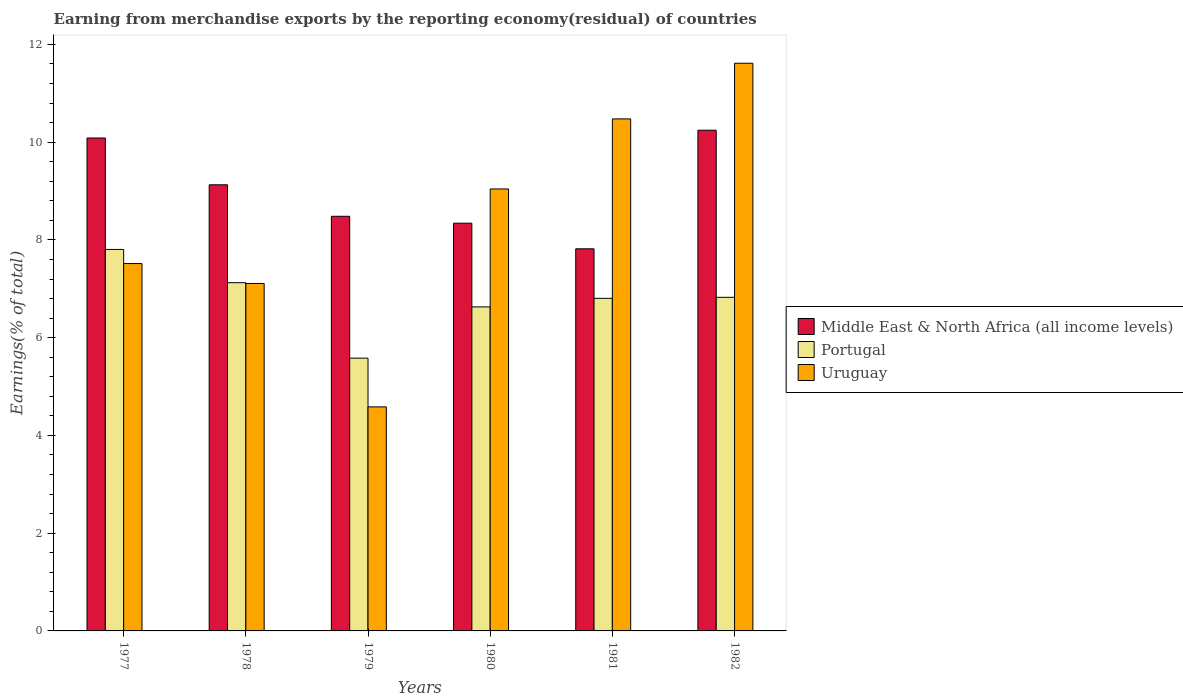Are the number of bars per tick equal to the number of legend labels?
Make the answer very short. Yes. Are the number of bars on each tick of the X-axis equal?
Make the answer very short. Yes. What is the label of the 4th group of bars from the left?
Your answer should be very brief. 1980. In how many cases, is the number of bars for a given year not equal to the number of legend labels?
Ensure brevity in your answer.  0. What is the percentage of amount earned from merchandise exports in Uruguay in 1981?
Offer a terse response. 10.48. Across all years, what is the maximum percentage of amount earned from merchandise exports in Portugal?
Offer a terse response. 7.81. Across all years, what is the minimum percentage of amount earned from merchandise exports in Portugal?
Make the answer very short. 5.58. In which year was the percentage of amount earned from merchandise exports in Middle East & North Africa (all income levels) maximum?
Provide a short and direct response. 1982. In which year was the percentage of amount earned from merchandise exports in Uruguay minimum?
Provide a short and direct response. 1979. What is the total percentage of amount earned from merchandise exports in Middle East & North Africa (all income levels) in the graph?
Offer a very short reply. 54.1. What is the difference between the percentage of amount earned from merchandise exports in Portugal in 1977 and that in 1979?
Your answer should be compact. 2.22. What is the difference between the percentage of amount earned from merchandise exports in Portugal in 1981 and the percentage of amount earned from merchandise exports in Middle East & North Africa (all income levels) in 1982?
Your answer should be compact. -3.44. What is the average percentage of amount earned from merchandise exports in Uruguay per year?
Your response must be concise. 8.39. In the year 1979, what is the difference between the percentage of amount earned from merchandise exports in Middle East & North Africa (all income levels) and percentage of amount earned from merchandise exports in Uruguay?
Keep it short and to the point. 3.9. What is the ratio of the percentage of amount earned from merchandise exports in Portugal in 1979 to that in 1982?
Your response must be concise. 0.82. What is the difference between the highest and the second highest percentage of amount earned from merchandise exports in Middle East & North Africa (all income levels)?
Offer a terse response. 0.16. What is the difference between the highest and the lowest percentage of amount earned from merchandise exports in Portugal?
Make the answer very short. 2.22. Is the sum of the percentage of amount earned from merchandise exports in Middle East & North Africa (all income levels) in 1977 and 1980 greater than the maximum percentage of amount earned from merchandise exports in Uruguay across all years?
Make the answer very short. Yes. What does the 1st bar from the left in 1980 represents?
Your answer should be very brief. Middle East & North Africa (all income levels). What does the 3rd bar from the right in 1977 represents?
Keep it short and to the point. Middle East & North Africa (all income levels). Is it the case that in every year, the sum of the percentage of amount earned from merchandise exports in Portugal and percentage of amount earned from merchandise exports in Uruguay is greater than the percentage of amount earned from merchandise exports in Middle East & North Africa (all income levels)?
Your answer should be very brief. Yes. How many bars are there?
Give a very brief answer. 18. Are all the bars in the graph horizontal?
Make the answer very short. No. How many years are there in the graph?
Give a very brief answer. 6. What is the title of the graph?
Provide a short and direct response. Earning from merchandise exports by the reporting economy(residual) of countries. What is the label or title of the Y-axis?
Provide a short and direct response. Earnings(% of total). What is the Earnings(% of total) of Middle East & North Africa (all income levels) in 1977?
Offer a terse response. 10.09. What is the Earnings(% of total) of Portugal in 1977?
Offer a terse response. 7.81. What is the Earnings(% of total) of Uruguay in 1977?
Your response must be concise. 7.52. What is the Earnings(% of total) in Middle East & North Africa (all income levels) in 1978?
Your answer should be compact. 9.13. What is the Earnings(% of total) in Portugal in 1978?
Make the answer very short. 7.13. What is the Earnings(% of total) in Uruguay in 1978?
Offer a very short reply. 7.11. What is the Earnings(% of total) in Middle East & North Africa (all income levels) in 1979?
Your response must be concise. 8.48. What is the Earnings(% of total) of Portugal in 1979?
Your answer should be compact. 5.58. What is the Earnings(% of total) in Uruguay in 1979?
Your answer should be compact. 4.58. What is the Earnings(% of total) of Middle East & North Africa (all income levels) in 1980?
Provide a succinct answer. 8.34. What is the Earnings(% of total) in Portugal in 1980?
Offer a very short reply. 6.63. What is the Earnings(% of total) of Uruguay in 1980?
Your response must be concise. 9.04. What is the Earnings(% of total) of Middle East & North Africa (all income levels) in 1981?
Keep it short and to the point. 7.82. What is the Earnings(% of total) in Portugal in 1981?
Ensure brevity in your answer.  6.81. What is the Earnings(% of total) of Uruguay in 1981?
Ensure brevity in your answer.  10.48. What is the Earnings(% of total) in Middle East & North Africa (all income levels) in 1982?
Provide a succinct answer. 10.25. What is the Earnings(% of total) in Portugal in 1982?
Your response must be concise. 6.83. What is the Earnings(% of total) of Uruguay in 1982?
Your answer should be very brief. 11.62. Across all years, what is the maximum Earnings(% of total) in Middle East & North Africa (all income levels)?
Your answer should be compact. 10.25. Across all years, what is the maximum Earnings(% of total) in Portugal?
Your answer should be compact. 7.81. Across all years, what is the maximum Earnings(% of total) in Uruguay?
Offer a terse response. 11.62. Across all years, what is the minimum Earnings(% of total) in Middle East & North Africa (all income levels)?
Your response must be concise. 7.82. Across all years, what is the minimum Earnings(% of total) of Portugal?
Your answer should be compact. 5.58. Across all years, what is the minimum Earnings(% of total) in Uruguay?
Provide a short and direct response. 4.58. What is the total Earnings(% of total) in Middle East & North Africa (all income levels) in the graph?
Your answer should be very brief. 54.1. What is the total Earnings(% of total) of Portugal in the graph?
Your answer should be compact. 40.77. What is the total Earnings(% of total) in Uruguay in the graph?
Your response must be concise. 50.35. What is the difference between the Earnings(% of total) of Middle East & North Africa (all income levels) in 1977 and that in 1978?
Provide a short and direct response. 0.96. What is the difference between the Earnings(% of total) in Portugal in 1977 and that in 1978?
Your response must be concise. 0.68. What is the difference between the Earnings(% of total) in Uruguay in 1977 and that in 1978?
Make the answer very short. 0.41. What is the difference between the Earnings(% of total) of Middle East & North Africa (all income levels) in 1977 and that in 1979?
Provide a short and direct response. 1.6. What is the difference between the Earnings(% of total) of Portugal in 1977 and that in 1979?
Provide a succinct answer. 2.22. What is the difference between the Earnings(% of total) in Uruguay in 1977 and that in 1979?
Provide a short and direct response. 2.93. What is the difference between the Earnings(% of total) of Middle East & North Africa (all income levels) in 1977 and that in 1980?
Your response must be concise. 1.74. What is the difference between the Earnings(% of total) of Portugal in 1977 and that in 1980?
Ensure brevity in your answer.  1.18. What is the difference between the Earnings(% of total) of Uruguay in 1977 and that in 1980?
Provide a succinct answer. -1.53. What is the difference between the Earnings(% of total) in Middle East & North Africa (all income levels) in 1977 and that in 1981?
Give a very brief answer. 2.27. What is the difference between the Earnings(% of total) of Portugal in 1977 and that in 1981?
Offer a very short reply. 1. What is the difference between the Earnings(% of total) in Uruguay in 1977 and that in 1981?
Offer a very short reply. -2.96. What is the difference between the Earnings(% of total) of Middle East & North Africa (all income levels) in 1977 and that in 1982?
Offer a terse response. -0.16. What is the difference between the Earnings(% of total) of Portugal in 1977 and that in 1982?
Ensure brevity in your answer.  0.98. What is the difference between the Earnings(% of total) of Uruguay in 1977 and that in 1982?
Offer a terse response. -4.1. What is the difference between the Earnings(% of total) in Middle East & North Africa (all income levels) in 1978 and that in 1979?
Keep it short and to the point. 0.64. What is the difference between the Earnings(% of total) of Portugal in 1978 and that in 1979?
Your answer should be compact. 1.54. What is the difference between the Earnings(% of total) of Uruguay in 1978 and that in 1979?
Offer a very short reply. 2.53. What is the difference between the Earnings(% of total) of Middle East & North Africa (all income levels) in 1978 and that in 1980?
Give a very brief answer. 0.79. What is the difference between the Earnings(% of total) in Portugal in 1978 and that in 1980?
Your answer should be compact. 0.5. What is the difference between the Earnings(% of total) of Uruguay in 1978 and that in 1980?
Provide a short and direct response. -1.93. What is the difference between the Earnings(% of total) in Middle East & North Africa (all income levels) in 1978 and that in 1981?
Your answer should be very brief. 1.31. What is the difference between the Earnings(% of total) in Portugal in 1978 and that in 1981?
Offer a terse response. 0.32. What is the difference between the Earnings(% of total) of Uruguay in 1978 and that in 1981?
Your answer should be compact. -3.37. What is the difference between the Earnings(% of total) in Middle East & North Africa (all income levels) in 1978 and that in 1982?
Keep it short and to the point. -1.12. What is the difference between the Earnings(% of total) in Portugal in 1978 and that in 1982?
Make the answer very short. 0.3. What is the difference between the Earnings(% of total) in Uruguay in 1978 and that in 1982?
Keep it short and to the point. -4.51. What is the difference between the Earnings(% of total) in Middle East & North Africa (all income levels) in 1979 and that in 1980?
Your response must be concise. 0.14. What is the difference between the Earnings(% of total) of Portugal in 1979 and that in 1980?
Your answer should be compact. -1.05. What is the difference between the Earnings(% of total) of Uruguay in 1979 and that in 1980?
Give a very brief answer. -4.46. What is the difference between the Earnings(% of total) in Middle East & North Africa (all income levels) in 1979 and that in 1981?
Provide a succinct answer. 0.67. What is the difference between the Earnings(% of total) in Portugal in 1979 and that in 1981?
Your answer should be compact. -1.22. What is the difference between the Earnings(% of total) of Uruguay in 1979 and that in 1981?
Provide a succinct answer. -5.89. What is the difference between the Earnings(% of total) of Middle East & North Africa (all income levels) in 1979 and that in 1982?
Make the answer very short. -1.76. What is the difference between the Earnings(% of total) in Portugal in 1979 and that in 1982?
Provide a succinct answer. -1.24. What is the difference between the Earnings(% of total) of Uruguay in 1979 and that in 1982?
Offer a terse response. -7.03. What is the difference between the Earnings(% of total) in Middle East & North Africa (all income levels) in 1980 and that in 1981?
Your response must be concise. 0.52. What is the difference between the Earnings(% of total) in Portugal in 1980 and that in 1981?
Your answer should be compact. -0.18. What is the difference between the Earnings(% of total) in Uruguay in 1980 and that in 1981?
Keep it short and to the point. -1.43. What is the difference between the Earnings(% of total) in Middle East & North Africa (all income levels) in 1980 and that in 1982?
Make the answer very short. -1.9. What is the difference between the Earnings(% of total) of Portugal in 1980 and that in 1982?
Give a very brief answer. -0.2. What is the difference between the Earnings(% of total) in Uruguay in 1980 and that in 1982?
Your answer should be compact. -2.57. What is the difference between the Earnings(% of total) of Middle East & North Africa (all income levels) in 1981 and that in 1982?
Provide a short and direct response. -2.43. What is the difference between the Earnings(% of total) of Portugal in 1981 and that in 1982?
Your answer should be compact. -0.02. What is the difference between the Earnings(% of total) of Uruguay in 1981 and that in 1982?
Keep it short and to the point. -1.14. What is the difference between the Earnings(% of total) in Middle East & North Africa (all income levels) in 1977 and the Earnings(% of total) in Portugal in 1978?
Your response must be concise. 2.96. What is the difference between the Earnings(% of total) of Middle East & North Africa (all income levels) in 1977 and the Earnings(% of total) of Uruguay in 1978?
Your answer should be compact. 2.98. What is the difference between the Earnings(% of total) in Portugal in 1977 and the Earnings(% of total) in Uruguay in 1978?
Give a very brief answer. 0.7. What is the difference between the Earnings(% of total) in Middle East & North Africa (all income levels) in 1977 and the Earnings(% of total) in Portugal in 1979?
Give a very brief answer. 4.5. What is the difference between the Earnings(% of total) of Middle East & North Africa (all income levels) in 1977 and the Earnings(% of total) of Uruguay in 1979?
Provide a short and direct response. 5.5. What is the difference between the Earnings(% of total) in Portugal in 1977 and the Earnings(% of total) in Uruguay in 1979?
Your response must be concise. 3.22. What is the difference between the Earnings(% of total) in Middle East & North Africa (all income levels) in 1977 and the Earnings(% of total) in Portugal in 1980?
Offer a very short reply. 3.46. What is the difference between the Earnings(% of total) of Middle East & North Africa (all income levels) in 1977 and the Earnings(% of total) of Uruguay in 1980?
Provide a succinct answer. 1.04. What is the difference between the Earnings(% of total) of Portugal in 1977 and the Earnings(% of total) of Uruguay in 1980?
Give a very brief answer. -1.24. What is the difference between the Earnings(% of total) in Middle East & North Africa (all income levels) in 1977 and the Earnings(% of total) in Portugal in 1981?
Make the answer very short. 3.28. What is the difference between the Earnings(% of total) in Middle East & North Africa (all income levels) in 1977 and the Earnings(% of total) in Uruguay in 1981?
Give a very brief answer. -0.39. What is the difference between the Earnings(% of total) in Portugal in 1977 and the Earnings(% of total) in Uruguay in 1981?
Provide a short and direct response. -2.67. What is the difference between the Earnings(% of total) of Middle East & North Africa (all income levels) in 1977 and the Earnings(% of total) of Portugal in 1982?
Ensure brevity in your answer.  3.26. What is the difference between the Earnings(% of total) in Middle East & North Africa (all income levels) in 1977 and the Earnings(% of total) in Uruguay in 1982?
Ensure brevity in your answer.  -1.53. What is the difference between the Earnings(% of total) of Portugal in 1977 and the Earnings(% of total) of Uruguay in 1982?
Provide a succinct answer. -3.81. What is the difference between the Earnings(% of total) in Middle East & North Africa (all income levels) in 1978 and the Earnings(% of total) in Portugal in 1979?
Your answer should be compact. 3.55. What is the difference between the Earnings(% of total) of Middle East & North Africa (all income levels) in 1978 and the Earnings(% of total) of Uruguay in 1979?
Offer a very short reply. 4.54. What is the difference between the Earnings(% of total) in Portugal in 1978 and the Earnings(% of total) in Uruguay in 1979?
Offer a very short reply. 2.54. What is the difference between the Earnings(% of total) of Middle East & North Africa (all income levels) in 1978 and the Earnings(% of total) of Portugal in 1980?
Keep it short and to the point. 2.5. What is the difference between the Earnings(% of total) in Middle East & North Africa (all income levels) in 1978 and the Earnings(% of total) in Uruguay in 1980?
Your response must be concise. 0.09. What is the difference between the Earnings(% of total) of Portugal in 1978 and the Earnings(% of total) of Uruguay in 1980?
Give a very brief answer. -1.92. What is the difference between the Earnings(% of total) of Middle East & North Africa (all income levels) in 1978 and the Earnings(% of total) of Portugal in 1981?
Your answer should be compact. 2.32. What is the difference between the Earnings(% of total) of Middle East & North Africa (all income levels) in 1978 and the Earnings(% of total) of Uruguay in 1981?
Keep it short and to the point. -1.35. What is the difference between the Earnings(% of total) in Portugal in 1978 and the Earnings(% of total) in Uruguay in 1981?
Make the answer very short. -3.35. What is the difference between the Earnings(% of total) of Middle East & North Africa (all income levels) in 1978 and the Earnings(% of total) of Portugal in 1982?
Keep it short and to the point. 2.3. What is the difference between the Earnings(% of total) in Middle East & North Africa (all income levels) in 1978 and the Earnings(% of total) in Uruguay in 1982?
Give a very brief answer. -2.49. What is the difference between the Earnings(% of total) in Portugal in 1978 and the Earnings(% of total) in Uruguay in 1982?
Provide a short and direct response. -4.49. What is the difference between the Earnings(% of total) in Middle East & North Africa (all income levels) in 1979 and the Earnings(% of total) in Portugal in 1980?
Keep it short and to the point. 1.85. What is the difference between the Earnings(% of total) in Middle East & North Africa (all income levels) in 1979 and the Earnings(% of total) in Uruguay in 1980?
Keep it short and to the point. -0.56. What is the difference between the Earnings(% of total) of Portugal in 1979 and the Earnings(% of total) of Uruguay in 1980?
Your answer should be very brief. -3.46. What is the difference between the Earnings(% of total) in Middle East & North Africa (all income levels) in 1979 and the Earnings(% of total) in Portugal in 1981?
Give a very brief answer. 1.68. What is the difference between the Earnings(% of total) of Middle East & North Africa (all income levels) in 1979 and the Earnings(% of total) of Uruguay in 1981?
Offer a terse response. -1.99. What is the difference between the Earnings(% of total) in Portugal in 1979 and the Earnings(% of total) in Uruguay in 1981?
Make the answer very short. -4.9. What is the difference between the Earnings(% of total) in Middle East & North Africa (all income levels) in 1979 and the Earnings(% of total) in Portugal in 1982?
Provide a succinct answer. 1.66. What is the difference between the Earnings(% of total) of Middle East & North Africa (all income levels) in 1979 and the Earnings(% of total) of Uruguay in 1982?
Offer a terse response. -3.13. What is the difference between the Earnings(% of total) in Portugal in 1979 and the Earnings(% of total) in Uruguay in 1982?
Offer a terse response. -6.03. What is the difference between the Earnings(% of total) in Middle East & North Africa (all income levels) in 1980 and the Earnings(% of total) in Portugal in 1981?
Keep it short and to the point. 1.54. What is the difference between the Earnings(% of total) in Middle East & North Africa (all income levels) in 1980 and the Earnings(% of total) in Uruguay in 1981?
Offer a terse response. -2.13. What is the difference between the Earnings(% of total) in Portugal in 1980 and the Earnings(% of total) in Uruguay in 1981?
Your answer should be compact. -3.85. What is the difference between the Earnings(% of total) in Middle East & North Africa (all income levels) in 1980 and the Earnings(% of total) in Portugal in 1982?
Your response must be concise. 1.52. What is the difference between the Earnings(% of total) of Middle East & North Africa (all income levels) in 1980 and the Earnings(% of total) of Uruguay in 1982?
Provide a short and direct response. -3.27. What is the difference between the Earnings(% of total) of Portugal in 1980 and the Earnings(% of total) of Uruguay in 1982?
Offer a very short reply. -4.99. What is the difference between the Earnings(% of total) in Middle East & North Africa (all income levels) in 1981 and the Earnings(% of total) in Portugal in 1982?
Make the answer very short. 0.99. What is the difference between the Earnings(% of total) in Middle East & North Africa (all income levels) in 1981 and the Earnings(% of total) in Uruguay in 1982?
Your answer should be very brief. -3.8. What is the difference between the Earnings(% of total) in Portugal in 1981 and the Earnings(% of total) in Uruguay in 1982?
Offer a terse response. -4.81. What is the average Earnings(% of total) in Middle East & North Africa (all income levels) per year?
Give a very brief answer. 9.02. What is the average Earnings(% of total) of Portugal per year?
Your answer should be very brief. 6.8. What is the average Earnings(% of total) in Uruguay per year?
Offer a terse response. 8.39. In the year 1977, what is the difference between the Earnings(% of total) of Middle East & North Africa (all income levels) and Earnings(% of total) of Portugal?
Provide a succinct answer. 2.28. In the year 1977, what is the difference between the Earnings(% of total) in Middle East & North Africa (all income levels) and Earnings(% of total) in Uruguay?
Your response must be concise. 2.57. In the year 1977, what is the difference between the Earnings(% of total) of Portugal and Earnings(% of total) of Uruguay?
Give a very brief answer. 0.29. In the year 1978, what is the difference between the Earnings(% of total) in Middle East & North Africa (all income levels) and Earnings(% of total) in Portugal?
Give a very brief answer. 2. In the year 1978, what is the difference between the Earnings(% of total) of Middle East & North Africa (all income levels) and Earnings(% of total) of Uruguay?
Keep it short and to the point. 2.02. In the year 1978, what is the difference between the Earnings(% of total) in Portugal and Earnings(% of total) in Uruguay?
Your response must be concise. 0.02. In the year 1979, what is the difference between the Earnings(% of total) in Middle East & North Africa (all income levels) and Earnings(% of total) in Portugal?
Offer a very short reply. 2.9. In the year 1979, what is the difference between the Earnings(% of total) of Middle East & North Africa (all income levels) and Earnings(% of total) of Uruguay?
Your response must be concise. 3.9. In the year 1980, what is the difference between the Earnings(% of total) of Middle East & North Africa (all income levels) and Earnings(% of total) of Portugal?
Your response must be concise. 1.71. In the year 1980, what is the difference between the Earnings(% of total) in Middle East & North Africa (all income levels) and Earnings(% of total) in Uruguay?
Keep it short and to the point. -0.7. In the year 1980, what is the difference between the Earnings(% of total) of Portugal and Earnings(% of total) of Uruguay?
Keep it short and to the point. -2.41. In the year 1981, what is the difference between the Earnings(% of total) in Middle East & North Africa (all income levels) and Earnings(% of total) in Portugal?
Offer a terse response. 1.01. In the year 1981, what is the difference between the Earnings(% of total) in Middle East & North Africa (all income levels) and Earnings(% of total) in Uruguay?
Make the answer very short. -2.66. In the year 1981, what is the difference between the Earnings(% of total) of Portugal and Earnings(% of total) of Uruguay?
Your answer should be very brief. -3.67. In the year 1982, what is the difference between the Earnings(% of total) of Middle East & North Africa (all income levels) and Earnings(% of total) of Portugal?
Your response must be concise. 3.42. In the year 1982, what is the difference between the Earnings(% of total) in Middle East & North Africa (all income levels) and Earnings(% of total) in Uruguay?
Keep it short and to the point. -1.37. In the year 1982, what is the difference between the Earnings(% of total) in Portugal and Earnings(% of total) in Uruguay?
Your answer should be very brief. -4.79. What is the ratio of the Earnings(% of total) of Middle East & North Africa (all income levels) in 1977 to that in 1978?
Offer a very short reply. 1.1. What is the ratio of the Earnings(% of total) in Portugal in 1977 to that in 1978?
Your response must be concise. 1.1. What is the ratio of the Earnings(% of total) of Uruguay in 1977 to that in 1978?
Your response must be concise. 1.06. What is the ratio of the Earnings(% of total) of Middle East & North Africa (all income levels) in 1977 to that in 1979?
Offer a terse response. 1.19. What is the ratio of the Earnings(% of total) of Portugal in 1977 to that in 1979?
Keep it short and to the point. 1.4. What is the ratio of the Earnings(% of total) in Uruguay in 1977 to that in 1979?
Give a very brief answer. 1.64. What is the ratio of the Earnings(% of total) in Middle East & North Africa (all income levels) in 1977 to that in 1980?
Provide a succinct answer. 1.21. What is the ratio of the Earnings(% of total) in Portugal in 1977 to that in 1980?
Ensure brevity in your answer.  1.18. What is the ratio of the Earnings(% of total) of Uruguay in 1977 to that in 1980?
Offer a very short reply. 0.83. What is the ratio of the Earnings(% of total) of Middle East & North Africa (all income levels) in 1977 to that in 1981?
Offer a terse response. 1.29. What is the ratio of the Earnings(% of total) in Portugal in 1977 to that in 1981?
Give a very brief answer. 1.15. What is the ratio of the Earnings(% of total) in Uruguay in 1977 to that in 1981?
Your response must be concise. 0.72. What is the ratio of the Earnings(% of total) in Middle East & North Africa (all income levels) in 1977 to that in 1982?
Your response must be concise. 0.98. What is the ratio of the Earnings(% of total) in Portugal in 1977 to that in 1982?
Provide a short and direct response. 1.14. What is the ratio of the Earnings(% of total) in Uruguay in 1977 to that in 1982?
Keep it short and to the point. 0.65. What is the ratio of the Earnings(% of total) in Middle East & North Africa (all income levels) in 1978 to that in 1979?
Your answer should be very brief. 1.08. What is the ratio of the Earnings(% of total) in Portugal in 1978 to that in 1979?
Offer a very short reply. 1.28. What is the ratio of the Earnings(% of total) in Uruguay in 1978 to that in 1979?
Your answer should be very brief. 1.55. What is the ratio of the Earnings(% of total) in Middle East & North Africa (all income levels) in 1978 to that in 1980?
Offer a very short reply. 1.09. What is the ratio of the Earnings(% of total) in Portugal in 1978 to that in 1980?
Give a very brief answer. 1.07. What is the ratio of the Earnings(% of total) of Uruguay in 1978 to that in 1980?
Provide a short and direct response. 0.79. What is the ratio of the Earnings(% of total) in Middle East & North Africa (all income levels) in 1978 to that in 1981?
Keep it short and to the point. 1.17. What is the ratio of the Earnings(% of total) in Portugal in 1978 to that in 1981?
Provide a succinct answer. 1.05. What is the ratio of the Earnings(% of total) in Uruguay in 1978 to that in 1981?
Offer a very short reply. 0.68. What is the ratio of the Earnings(% of total) of Middle East & North Africa (all income levels) in 1978 to that in 1982?
Your response must be concise. 0.89. What is the ratio of the Earnings(% of total) in Portugal in 1978 to that in 1982?
Offer a terse response. 1.04. What is the ratio of the Earnings(% of total) of Uruguay in 1978 to that in 1982?
Your response must be concise. 0.61. What is the ratio of the Earnings(% of total) of Middle East & North Africa (all income levels) in 1979 to that in 1980?
Offer a very short reply. 1.02. What is the ratio of the Earnings(% of total) in Portugal in 1979 to that in 1980?
Provide a succinct answer. 0.84. What is the ratio of the Earnings(% of total) in Uruguay in 1979 to that in 1980?
Give a very brief answer. 0.51. What is the ratio of the Earnings(% of total) of Middle East & North Africa (all income levels) in 1979 to that in 1981?
Give a very brief answer. 1.09. What is the ratio of the Earnings(% of total) in Portugal in 1979 to that in 1981?
Your answer should be compact. 0.82. What is the ratio of the Earnings(% of total) in Uruguay in 1979 to that in 1981?
Give a very brief answer. 0.44. What is the ratio of the Earnings(% of total) of Middle East & North Africa (all income levels) in 1979 to that in 1982?
Your answer should be compact. 0.83. What is the ratio of the Earnings(% of total) in Portugal in 1979 to that in 1982?
Offer a very short reply. 0.82. What is the ratio of the Earnings(% of total) in Uruguay in 1979 to that in 1982?
Offer a terse response. 0.39. What is the ratio of the Earnings(% of total) in Middle East & North Africa (all income levels) in 1980 to that in 1981?
Provide a succinct answer. 1.07. What is the ratio of the Earnings(% of total) in Portugal in 1980 to that in 1981?
Offer a very short reply. 0.97. What is the ratio of the Earnings(% of total) in Uruguay in 1980 to that in 1981?
Make the answer very short. 0.86. What is the ratio of the Earnings(% of total) in Middle East & North Africa (all income levels) in 1980 to that in 1982?
Offer a terse response. 0.81. What is the ratio of the Earnings(% of total) of Portugal in 1980 to that in 1982?
Offer a terse response. 0.97. What is the ratio of the Earnings(% of total) of Uruguay in 1980 to that in 1982?
Your answer should be very brief. 0.78. What is the ratio of the Earnings(% of total) in Middle East & North Africa (all income levels) in 1981 to that in 1982?
Offer a terse response. 0.76. What is the ratio of the Earnings(% of total) in Uruguay in 1981 to that in 1982?
Your answer should be compact. 0.9. What is the difference between the highest and the second highest Earnings(% of total) of Middle East & North Africa (all income levels)?
Give a very brief answer. 0.16. What is the difference between the highest and the second highest Earnings(% of total) of Portugal?
Provide a short and direct response. 0.68. What is the difference between the highest and the second highest Earnings(% of total) in Uruguay?
Keep it short and to the point. 1.14. What is the difference between the highest and the lowest Earnings(% of total) of Middle East & North Africa (all income levels)?
Your answer should be compact. 2.43. What is the difference between the highest and the lowest Earnings(% of total) in Portugal?
Make the answer very short. 2.22. What is the difference between the highest and the lowest Earnings(% of total) of Uruguay?
Your response must be concise. 7.03. 